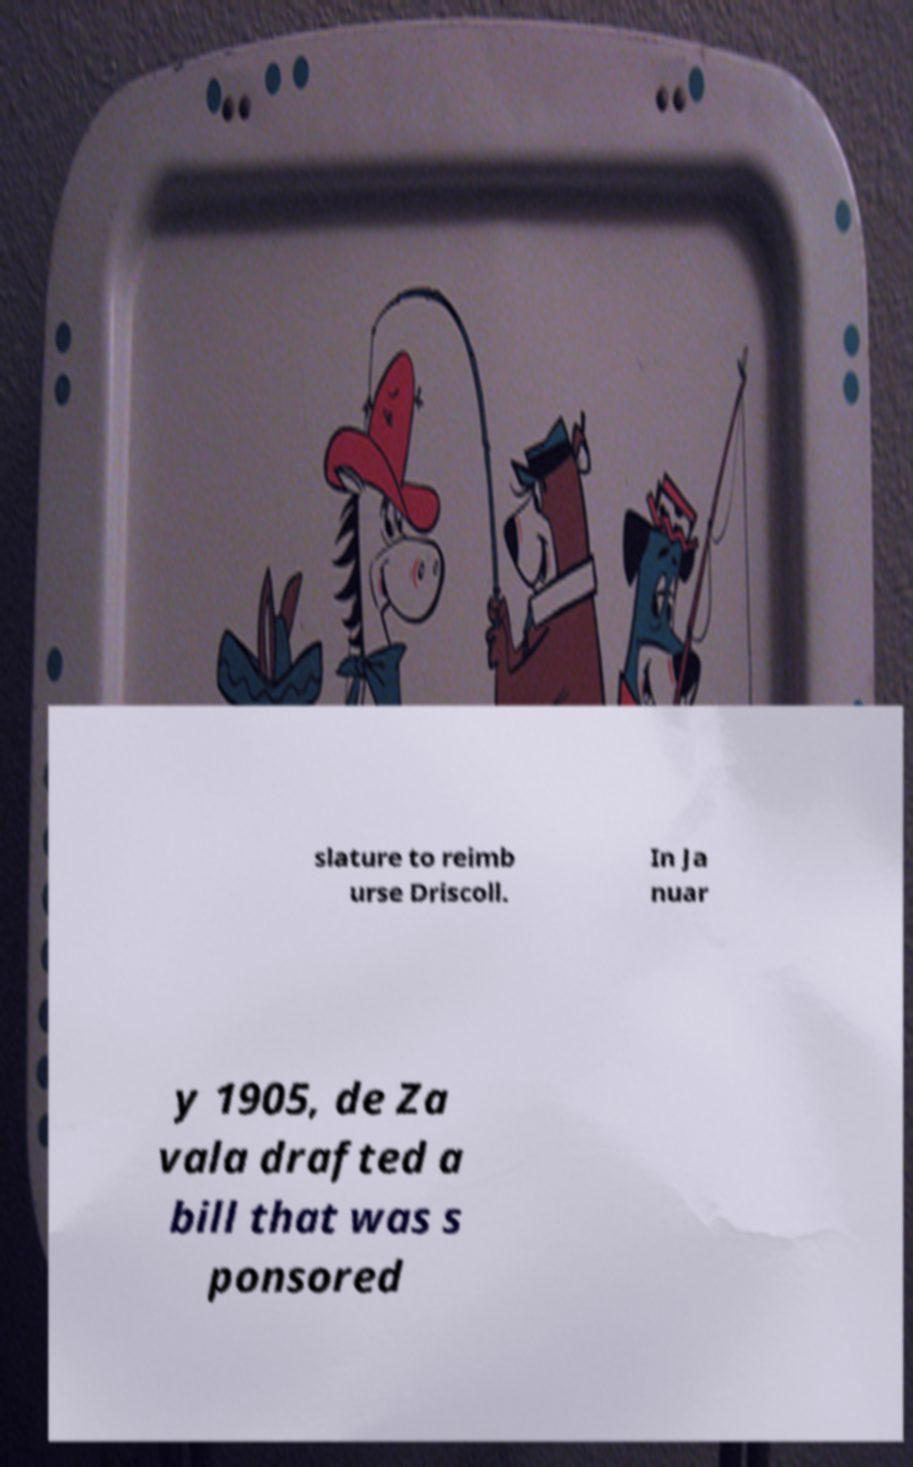For documentation purposes, I need the text within this image transcribed. Could you provide that? slature to reimb urse Driscoll. In Ja nuar y 1905, de Za vala drafted a bill that was s ponsored 